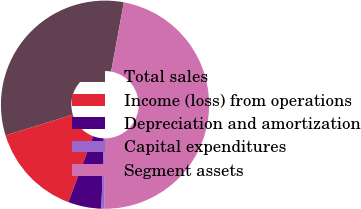Convert chart. <chart><loc_0><loc_0><loc_500><loc_500><pie_chart><fcel>Total sales<fcel>Income (loss) from operations<fcel>Depreciation and amortization<fcel>Capital expenditures<fcel>Segment assets<nl><fcel>32.68%<fcel>14.5%<fcel>5.17%<fcel>0.51%<fcel>47.15%<nl></chart> 